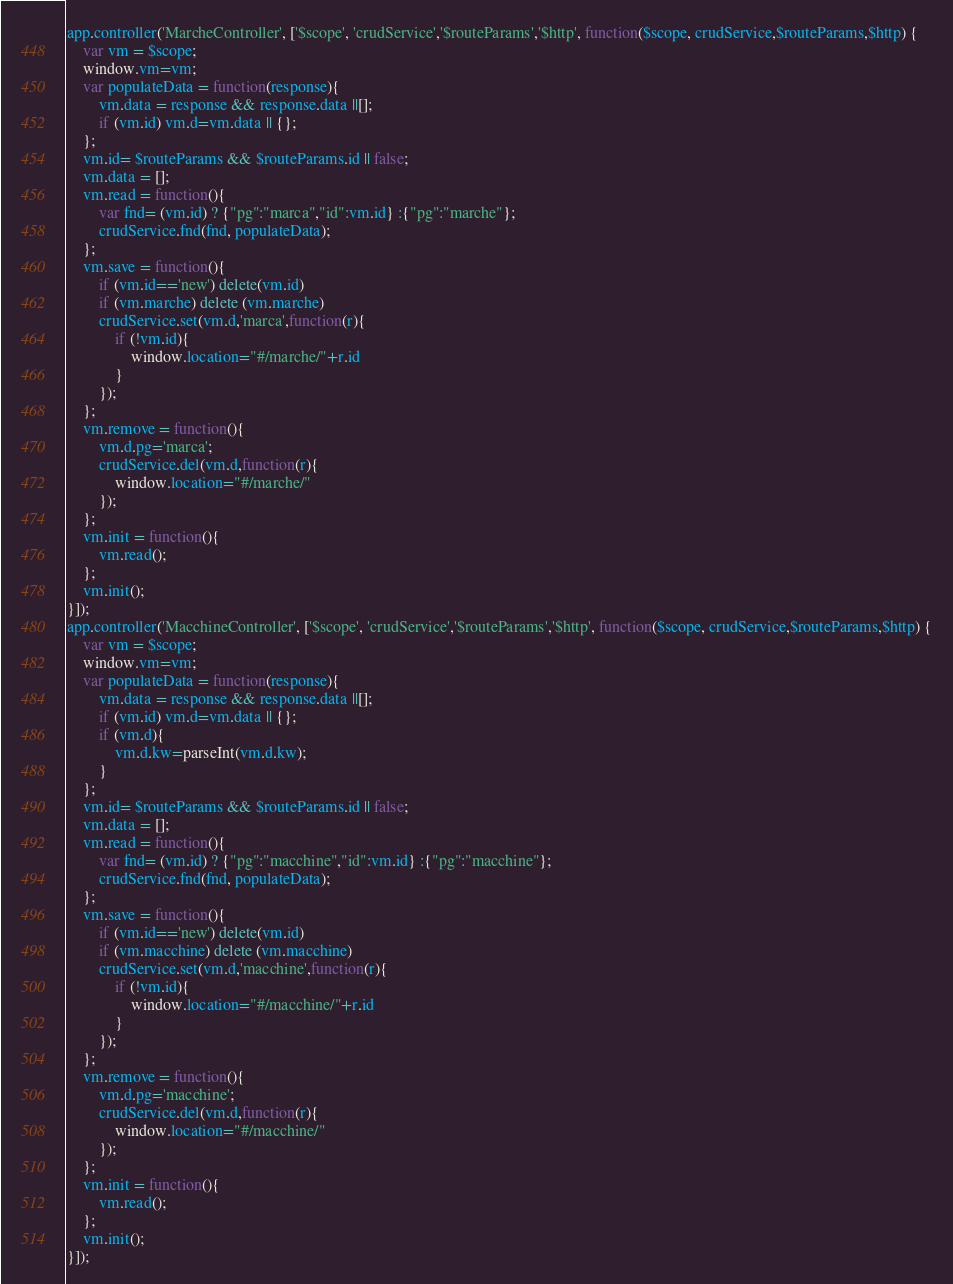<code> <loc_0><loc_0><loc_500><loc_500><_JavaScript_>app.controller('MarcheController', ['$scope', 'crudService','$routeParams','$http', function($scope, crudService,$routeParams,$http) {
    var vm = $scope;
	window.vm=vm;
    var populateData = function(response){
        vm.data = response && response.data ||[];
		if (vm.id) vm.d=vm.data || {};
    };
	vm.id= $routeParams && $routeParams.id || false;
    vm.data = [];
    vm.read = function(){
		var fnd= (vm.id) ? {"pg":"marca","id":vm.id} :{"pg":"marche"};
        crudService.fnd(fnd, populateData);
    };	
    vm.save = function(){
		if (vm.id=='new') delete(vm.id)
		if (vm.marche) delete (vm.marche)
        crudService.set(vm.d,'marca',function(r){
			if (!vm.id){
				window.location="#/marche/"+r.id
			}
		});
    };
	vm.remove = function(){
		vm.d.pg='marca';
        crudService.del(vm.d,function(r){
			window.location="#/marche/"
		});
    };
    vm.init = function(){
        vm.read();
    };
	vm.init();
}]);
app.controller('MacchineController', ['$scope', 'crudService','$routeParams','$http', function($scope, crudService,$routeParams,$http) {
    var vm = $scope;
	window.vm=vm;
    var populateData = function(response){
        vm.data = response && response.data ||[];
		if (vm.id) vm.d=vm.data || {};
		if (vm.d){ 
			vm.d.kw=parseInt(vm.d.kw);
		}
    };
	vm.id= $routeParams && $routeParams.id || false;
    vm.data = [];
    vm.read = function(){
		var fnd= (vm.id) ? {"pg":"macchine","id":vm.id} :{"pg":"macchine"};
        crudService.fnd(fnd, populateData);
    };	
    vm.save = function(){
		if (vm.id=='new') delete(vm.id)
		if (vm.macchine) delete (vm.macchine)
        crudService.set(vm.d,'macchine',function(r){
			if (!vm.id){
				window.location="#/macchine/"+r.id
			}
		});
    };
	vm.remove = function(){
		vm.d.pg='macchine';
        crudService.del(vm.d,function(r){
			window.location="#/macchine/"
		});
    };
    vm.init = function(){
        vm.read();
    };
	vm.init();
}]);</code> 